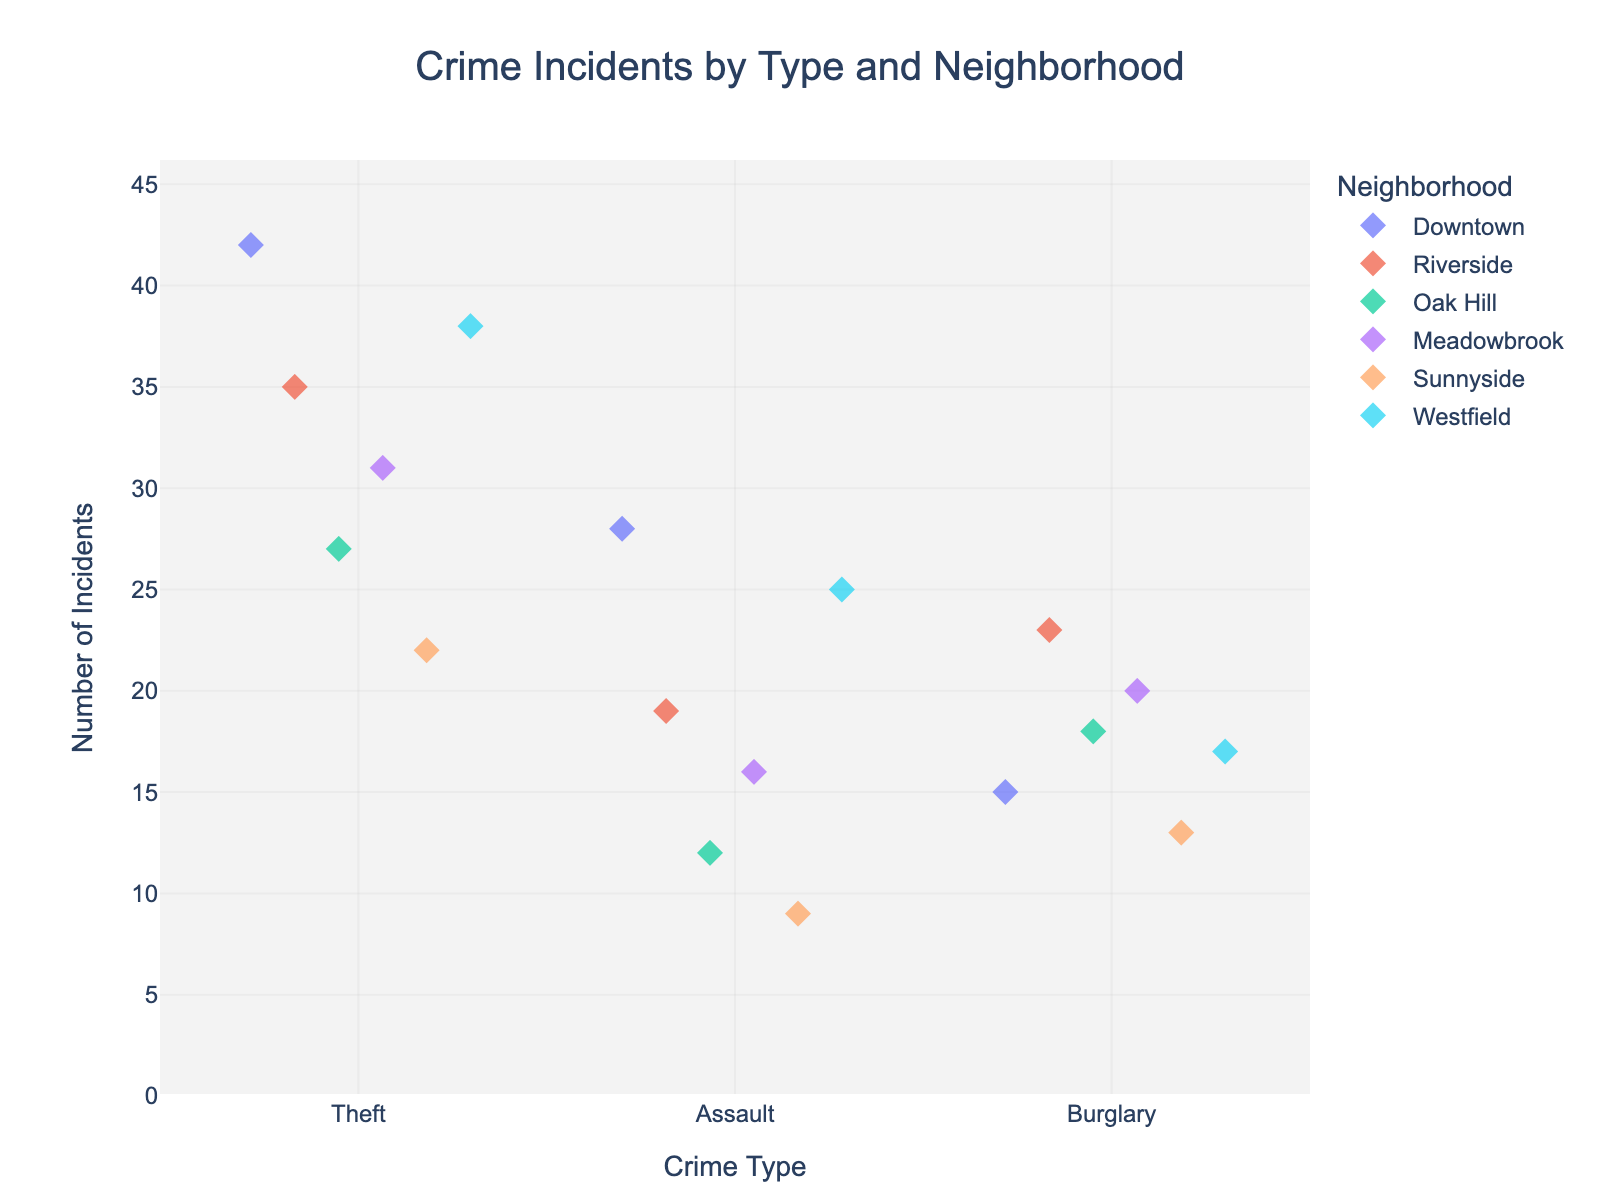What is the title of the plot? The title of the plot is displayed at the top center of the figure.
Answer: Crime Incidents by Type and Neighborhood How many crime types are shown in the plot? The x-axis lists the distinct crime types represented in the data. Count the unique labels.
Answer: 3 Which neighborhood has the highest number of theft incidents? Check the plot under the "Theft" category and identify the neighborhood with the highest data point.
Answer: Downtown How many neighborhoods are represented in the data? Look at the legend which lists all the neighborhoods indicated by different colors. Count them.
Answer: 6 What is the range of incidents in 'Burglary' across all neighborhoods? Observe the plot for 'Burglary' values on the y-axis from the minimum to the maximum.
Answer: 9 to 23 Which crime type has the highest average number of incidents across all neighborhoods? Find the average incidents for 'Theft', 'Assault', and 'Burglary' individually and compare.
Answer: Theft Which neighborhood has the lowest number of assault incidents? Check the plot under the "Assault" category and look for the neighborhood with the lowest value.
Answer: Sunnyside Compare the number of burglary incidents in Downtown and Riverside. Which has more? Look at the 'Burglary' category and compare the data points for Downtown and Riverside on the y-axis.
Answer: Riverside How does the variability in theft incidents compare to burglary incidents across neighborhoods? Look at the spread (variability) of data points for 'Theft' and 'Burglary' categories on the plot. Note the distribution width for each crime type.
Answer: Theft incidents show more variability 